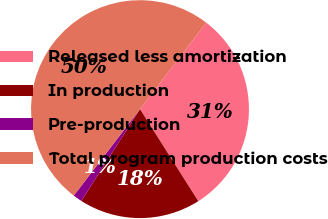<chart> <loc_0><loc_0><loc_500><loc_500><pie_chart><fcel>Released less amortization<fcel>In production<fcel>Pre-production<fcel>Total program production costs<nl><fcel>30.61%<fcel>18.04%<fcel>1.35%<fcel>50.0%<nl></chart> 